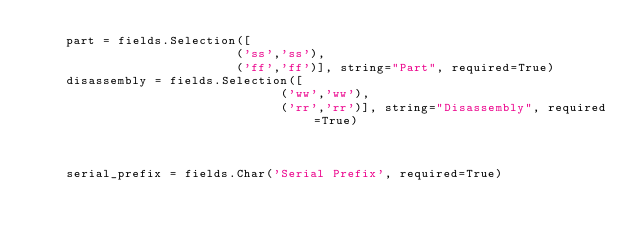Convert code to text. <code><loc_0><loc_0><loc_500><loc_500><_Python_>    part = fields.Selection([
                           ('ss','ss'),
                           ('ff','ff')], string="Part", required=True)
    disassembly = fields.Selection([
                                 ('ww','ww'),
                                 ('rr','rr')], string="Disassembly", required=True)
                                  
                                  
                                  
    serial_prefix = fields.Char('Serial Prefix', required=True)
    
    
                                   
</code> 